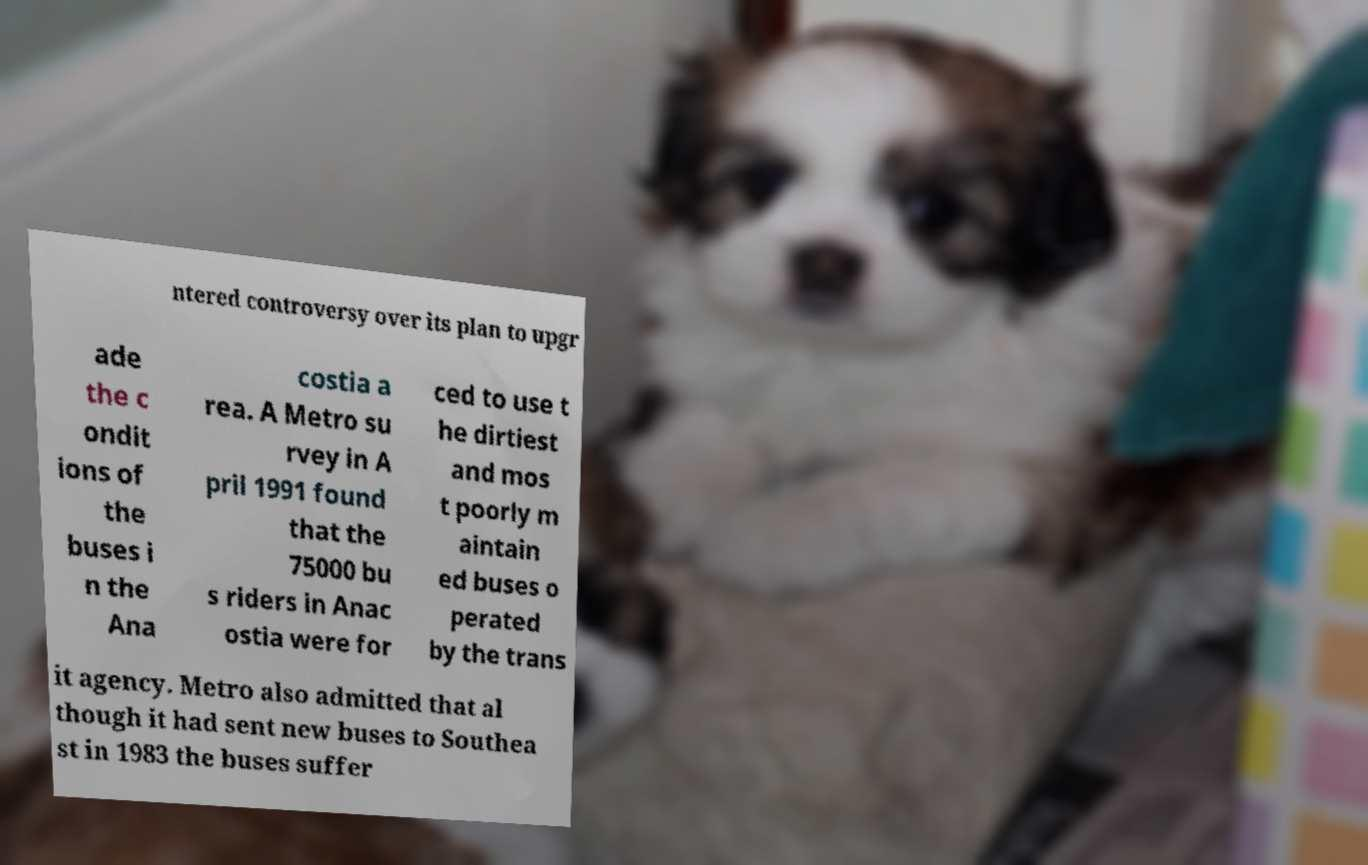Can you accurately transcribe the text from the provided image for me? ntered controversy over its plan to upgr ade the c ondit ions of the buses i n the Ana costia a rea. A Metro su rvey in A pril 1991 found that the 75000 bu s riders in Anac ostia were for ced to use t he dirtiest and mos t poorly m aintain ed buses o perated by the trans it agency. Metro also admitted that al though it had sent new buses to Southea st in 1983 the buses suffer 